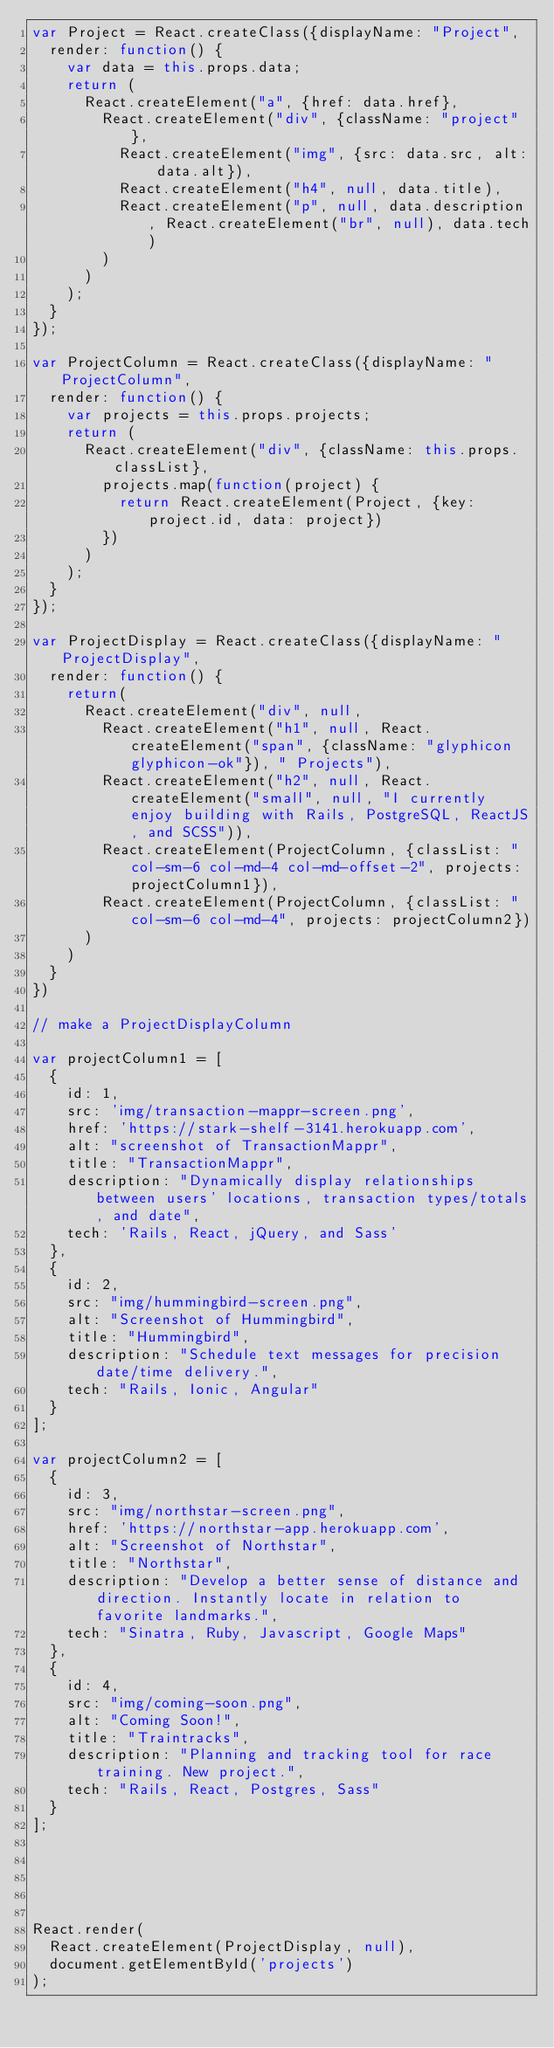Convert code to text. <code><loc_0><loc_0><loc_500><loc_500><_JavaScript_>var Project = React.createClass({displayName: "Project",
  render: function() {
    var data = this.props.data;
    return (
      React.createElement("a", {href: data.href}, 
        React.createElement("div", {className: "project"}, 
          React.createElement("img", {src: data.src, alt: data.alt}), 
          React.createElement("h4", null, data.title), 
          React.createElement("p", null, data.description, React.createElement("br", null), data.tech)
        )
      )
    );
  }
});

var ProjectColumn = React.createClass({displayName: "ProjectColumn",
  render: function() {
    var projects = this.props.projects;
    return (
      React.createElement("div", {className: this.props.classList}, 
        projects.map(function(project) {
          return React.createElement(Project, {key: project.id, data: project})
        })
      )
    );
  }
});

var ProjectDisplay = React.createClass({displayName: "ProjectDisplay",
  render: function() {
    return(
      React.createElement("div", null, 
        React.createElement("h1", null, React.createElement("span", {className: "glyphicon glyphicon-ok"}), " Projects"), 
        React.createElement("h2", null, React.createElement("small", null, "I currently enjoy building with Rails, PostgreSQL, ReactJS, and SCSS")), 
        React.createElement(ProjectColumn, {classList: "col-sm-6 col-md-4 col-md-offset-2", projects: projectColumn1}), 
        React.createElement(ProjectColumn, {classList: "col-sm-6 col-md-4", projects: projectColumn2})
      )
    )
  }
})

// make a ProjectDisplayColumn

var projectColumn1 = [
  {
    id: 1,
    src: 'img/transaction-mappr-screen.png',
    href: 'https://stark-shelf-3141.herokuapp.com',
    alt: "screenshot of TransactionMappr",
    title: "TransactionMappr",
    description: "Dynamically display relationships between users' locations, transaction types/totals, and date",
    tech: 'Rails, React, jQuery, and Sass'
  },
  {
    id: 2,
    src: "img/hummingbird-screen.png",
    alt: "Screenshot of Hummingbird",
    title: "Hummingbird",
    description: "Schedule text messages for precision date/time delivery.",
    tech: "Rails, Ionic, Angular"
  }
];

var projectColumn2 = [
  {
    id: 3,
    src: "img/northstar-screen.png",
    href: 'https://northstar-app.herokuapp.com',
    alt: "Screenshot of Northstar",
    title: "Northstar",
    description: "Develop a better sense of distance and direction. Instantly locate in relation to favorite landmarks.",
    tech: "Sinatra, Ruby, Javascript, Google Maps"
  },
  {
    id: 4,
    src: "img/coming-soon.png",
    alt: "Coming Soon!",
    title: "Traintracks",
    description: "Planning and tracking tool for race training. New project.",
    tech: "Rails, React, Postgres, Sass"
  }
];





React.render(
  React.createElement(ProjectDisplay, null),
  document.getElementById('projects')
);</code> 